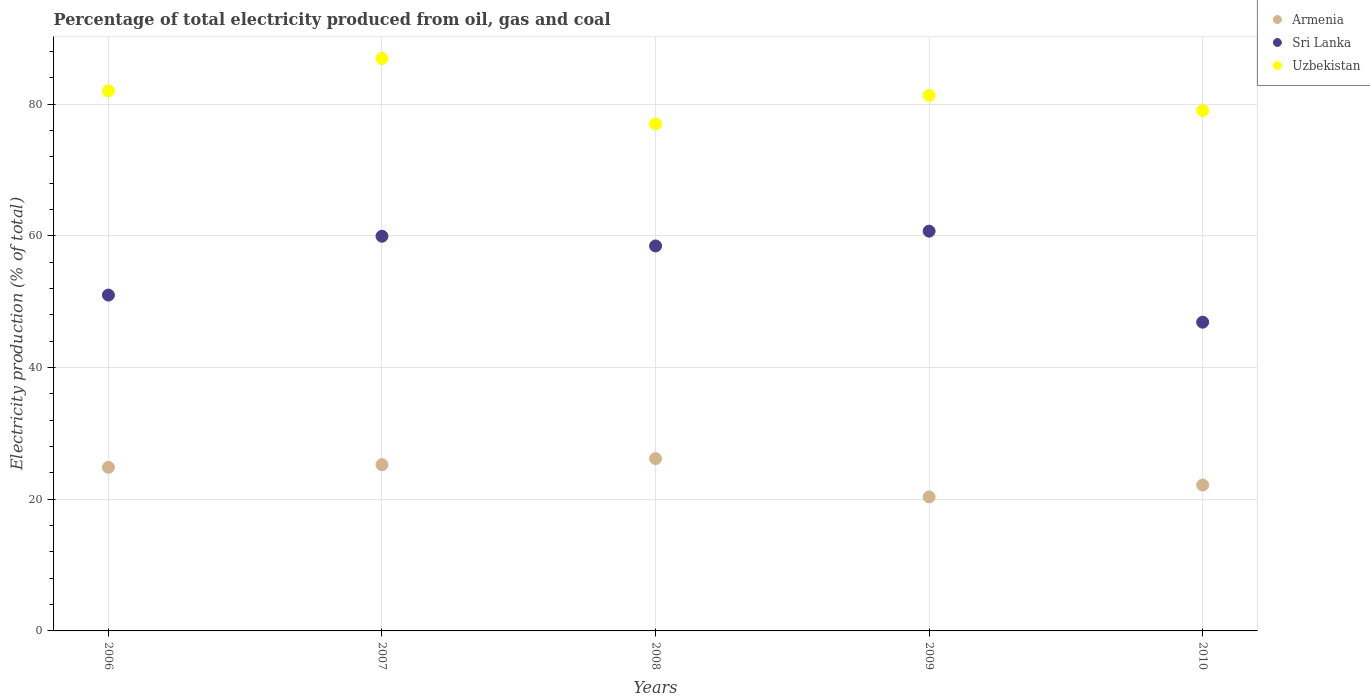How many different coloured dotlines are there?
Give a very brief answer. 3. Is the number of dotlines equal to the number of legend labels?
Your answer should be compact. Yes. What is the electricity production in in Armenia in 2006?
Provide a succinct answer. 24.84. Across all years, what is the maximum electricity production in in Uzbekistan?
Provide a succinct answer. 86.93. Across all years, what is the minimum electricity production in in Armenia?
Give a very brief answer. 20.35. In which year was the electricity production in in Sri Lanka minimum?
Keep it short and to the point. 2010. What is the total electricity production in in Sri Lanka in the graph?
Offer a very short reply. 276.98. What is the difference between the electricity production in in Sri Lanka in 2008 and that in 2009?
Provide a succinct answer. -2.24. What is the difference between the electricity production in in Sri Lanka in 2007 and the electricity production in in Uzbekistan in 2008?
Your answer should be compact. -17.07. What is the average electricity production in in Uzbekistan per year?
Make the answer very short. 81.26. In the year 2007, what is the difference between the electricity production in in Uzbekistan and electricity production in in Sri Lanka?
Offer a very short reply. 26.99. In how many years, is the electricity production in in Armenia greater than 72 %?
Provide a succinct answer. 0. What is the ratio of the electricity production in in Armenia in 2009 to that in 2010?
Your answer should be compact. 0.92. Is the difference between the electricity production in in Uzbekistan in 2008 and 2010 greater than the difference between the electricity production in in Sri Lanka in 2008 and 2010?
Make the answer very short. No. What is the difference between the highest and the second highest electricity production in in Uzbekistan?
Ensure brevity in your answer.  4.91. What is the difference between the highest and the lowest electricity production in in Sri Lanka?
Your answer should be compact. 13.82. In how many years, is the electricity production in in Uzbekistan greater than the average electricity production in in Uzbekistan taken over all years?
Give a very brief answer. 3. Is the sum of the electricity production in in Uzbekistan in 2007 and 2009 greater than the maximum electricity production in in Armenia across all years?
Offer a very short reply. Yes. Does the electricity production in in Sri Lanka monotonically increase over the years?
Your answer should be compact. No. How many years are there in the graph?
Offer a terse response. 5. Where does the legend appear in the graph?
Provide a succinct answer. Top right. What is the title of the graph?
Your response must be concise. Percentage of total electricity produced from oil, gas and coal. Does "Guatemala" appear as one of the legend labels in the graph?
Keep it short and to the point. No. What is the label or title of the X-axis?
Give a very brief answer. Years. What is the label or title of the Y-axis?
Your answer should be very brief. Electricity production (% of total). What is the Electricity production (% of total) in Armenia in 2006?
Your answer should be compact. 24.84. What is the Electricity production (% of total) in Sri Lanka in 2006?
Provide a succinct answer. 51. What is the Electricity production (% of total) in Uzbekistan in 2006?
Provide a short and direct response. 82.01. What is the Electricity production (% of total) of Armenia in 2007?
Make the answer very short. 25.25. What is the Electricity production (% of total) of Sri Lanka in 2007?
Offer a very short reply. 59.93. What is the Electricity production (% of total) of Uzbekistan in 2007?
Offer a terse response. 86.93. What is the Electricity production (% of total) in Armenia in 2008?
Your answer should be compact. 26.17. What is the Electricity production (% of total) of Sri Lanka in 2008?
Give a very brief answer. 58.46. What is the Electricity production (% of total) in Uzbekistan in 2008?
Offer a very short reply. 77. What is the Electricity production (% of total) of Armenia in 2009?
Provide a succinct answer. 20.35. What is the Electricity production (% of total) in Sri Lanka in 2009?
Provide a short and direct response. 60.7. What is the Electricity production (% of total) in Uzbekistan in 2009?
Ensure brevity in your answer.  81.32. What is the Electricity production (% of total) of Armenia in 2010?
Your response must be concise. 22.15. What is the Electricity production (% of total) of Sri Lanka in 2010?
Your answer should be very brief. 46.88. What is the Electricity production (% of total) of Uzbekistan in 2010?
Your answer should be very brief. 79.02. Across all years, what is the maximum Electricity production (% of total) in Armenia?
Provide a succinct answer. 26.17. Across all years, what is the maximum Electricity production (% of total) of Sri Lanka?
Make the answer very short. 60.7. Across all years, what is the maximum Electricity production (% of total) in Uzbekistan?
Your answer should be very brief. 86.93. Across all years, what is the minimum Electricity production (% of total) in Armenia?
Make the answer very short. 20.35. Across all years, what is the minimum Electricity production (% of total) in Sri Lanka?
Your response must be concise. 46.88. Across all years, what is the minimum Electricity production (% of total) in Uzbekistan?
Keep it short and to the point. 77. What is the total Electricity production (% of total) in Armenia in the graph?
Your answer should be very brief. 118.76. What is the total Electricity production (% of total) of Sri Lanka in the graph?
Provide a short and direct response. 276.98. What is the total Electricity production (% of total) in Uzbekistan in the graph?
Provide a succinct answer. 406.28. What is the difference between the Electricity production (% of total) of Armenia in 2006 and that in 2007?
Your answer should be very brief. -0.4. What is the difference between the Electricity production (% of total) of Sri Lanka in 2006 and that in 2007?
Provide a succinct answer. -8.93. What is the difference between the Electricity production (% of total) in Uzbekistan in 2006 and that in 2007?
Provide a short and direct response. -4.91. What is the difference between the Electricity production (% of total) in Armenia in 2006 and that in 2008?
Offer a terse response. -1.33. What is the difference between the Electricity production (% of total) in Sri Lanka in 2006 and that in 2008?
Provide a short and direct response. -7.46. What is the difference between the Electricity production (% of total) in Uzbekistan in 2006 and that in 2008?
Make the answer very short. 5.01. What is the difference between the Electricity production (% of total) in Armenia in 2006 and that in 2009?
Your answer should be compact. 4.5. What is the difference between the Electricity production (% of total) of Sri Lanka in 2006 and that in 2009?
Provide a succinct answer. -9.71. What is the difference between the Electricity production (% of total) in Uzbekistan in 2006 and that in 2009?
Give a very brief answer. 0.69. What is the difference between the Electricity production (% of total) in Armenia in 2006 and that in 2010?
Your response must be concise. 2.69. What is the difference between the Electricity production (% of total) in Sri Lanka in 2006 and that in 2010?
Keep it short and to the point. 4.12. What is the difference between the Electricity production (% of total) of Uzbekistan in 2006 and that in 2010?
Your answer should be very brief. 2.99. What is the difference between the Electricity production (% of total) of Armenia in 2007 and that in 2008?
Keep it short and to the point. -0.92. What is the difference between the Electricity production (% of total) of Sri Lanka in 2007 and that in 2008?
Provide a succinct answer. 1.47. What is the difference between the Electricity production (% of total) of Uzbekistan in 2007 and that in 2008?
Your answer should be very brief. 9.92. What is the difference between the Electricity production (% of total) in Armenia in 2007 and that in 2009?
Offer a terse response. 4.9. What is the difference between the Electricity production (% of total) in Sri Lanka in 2007 and that in 2009?
Give a very brief answer. -0.77. What is the difference between the Electricity production (% of total) in Uzbekistan in 2007 and that in 2009?
Your answer should be very brief. 5.6. What is the difference between the Electricity production (% of total) in Armenia in 2007 and that in 2010?
Offer a terse response. 3.09. What is the difference between the Electricity production (% of total) of Sri Lanka in 2007 and that in 2010?
Provide a short and direct response. 13.05. What is the difference between the Electricity production (% of total) in Uzbekistan in 2007 and that in 2010?
Offer a terse response. 7.9. What is the difference between the Electricity production (% of total) in Armenia in 2008 and that in 2009?
Ensure brevity in your answer.  5.82. What is the difference between the Electricity production (% of total) of Sri Lanka in 2008 and that in 2009?
Make the answer very short. -2.24. What is the difference between the Electricity production (% of total) of Uzbekistan in 2008 and that in 2009?
Keep it short and to the point. -4.32. What is the difference between the Electricity production (% of total) of Armenia in 2008 and that in 2010?
Provide a short and direct response. 4.02. What is the difference between the Electricity production (% of total) in Sri Lanka in 2008 and that in 2010?
Your answer should be compact. 11.58. What is the difference between the Electricity production (% of total) of Uzbekistan in 2008 and that in 2010?
Offer a very short reply. -2.02. What is the difference between the Electricity production (% of total) in Armenia in 2009 and that in 2010?
Your answer should be very brief. -1.8. What is the difference between the Electricity production (% of total) in Sri Lanka in 2009 and that in 2010?
Ensure brevity in your answer.  13.82. What is the difference between the Electricity production (% of total) of Uzbekistan in 2009 and that in 2010?
Make the answer very short. 2.3. What is the difference between the Electricity production (% of total) in Armenia in 2006 and the Electricity production (% of total) in Sri Lanka in 2007?
Your answer should be very brief. -35.09. What is the difference between the Electricity production (% of total) of Armenia in 2006 and the Electricity production (% of total) of Uzbekistan in 2007?
Make the answer very short. -62.08. What is the difference between the Electricity production (% of total) of Sri Lanka in 2006 and the Electricity production (% of total) of Uzbekistan in 2007?
Make the answer very short. -35.93. What is the difference between the Electricity production (% of total) of Armenia in 2006 and the Electricity production (% of total) of Sri Lanka in 2008?
Provide a short and direct response. -33.62. What is the difference between the Electricity production (% of total) in Armenia in 2006 and the Electricity production (% of total) in Uzbekistan in 2008?
Your response must be concise. -52.16. What is the difference between the Electricity production (% of total) of Sri Lanka in 2006 and the Electricity production (% of total) of Uzbekistan in 2008?
Provide a succinct answer. -26. What is the difference between the Electricity production (% of total) in Armenia in 2006 and the Electricity production (% of total) in Sri Lanka in 2009?
Keep it short and to the point. -35.86. What is the difference between the Electricity production (% of total) in Armenia in 2006 and the Electricity production (% of total) in Uzbekistan in 2009?
Your answer should be compact. -56.48. What is the difference between the Electricity production (% of total) in Sri Lanka in 2006 and the Electricity production (% of total) in Uzbekistan in 2009?
Make the answer very short. -30.32. What is the difference between the Electricity production (% of total) in Armenia in 2006 and the Electricity production (% of total) in Sri Lanka in 2010?
Your answer should be compact. -22.04. What is the difference between the Electricity production (% of total) of Armenia in 2006 and the Electricity production (% of total) of Uzbekistan in 2010?
Your response must be concise. -54.18. What is the difference between the Electricity production (% of total) in Sri Lanka in 2006 and the Electricity production (% of total) in Uzbekistan in 2010?
Your answer should be very brief. -28.02. What is the difference between the Electricity production (% of total) in Armenia in 2007 and the Electricity production (% of total) in Sri Lanka in 2008?
Provide a short and direct response. -33.21. What is the difference between the Electricity production (% of total) in Armenia in 2007 and the Electricity production (% of total) in Uzbekistan in 2008?
Offer a terse response. -51.76. What is the difference between the Electricity production (% of total) in Sri Lanka in 2007 and the Electricity production (% of total) in Uzbekistan in 2008?
Offer a terse response. -17.07. What is the difference between the Electricity production (% of total) of Armenia in 2007 and the Electricity production (% of total) of Sri Lanka in 2009?
Provide a short and direct response. -35.46. What is the difference between the Electricity production (% of total) in Armenia in 2007 and the Electricity production (% of total) in Uzbekistan in 2009?
Give a very brief answer. -56.08. What is the difference between the Electricity production (% of total) in Sri Lanka in 2007 and the Electricity production (% of total) in Uzbekistan in 2009?
Your answer should be very brief. -21.39. What is the difference between the Electricity production (% of total) in Armenia in 2007 and the Electricity production (% of total) in Sri Lanka in 2010?
Your answer should be compact. -21.64. What is the difference between the Electricity production (% of total) of Armenia in 2007 and the Electricity production (% of total) of Uzbekistan in 2010?
Ensure brevity in your answer.  -53.78. What is the difference between the Electricity production (% of total) in Sri Lanka in 2007 and the Electricity production (% of total) in Uzbekistan in 2010?
Ensure brevity in your answer.  -19.09. What is the difference between the Electricity production (% of total) of Armenia in 2008 and the Electricity production (% of total) of Sri Lanka in 2009?
Your answer should be compact. -34.54. What is the difference between the Electricity production (% of total) of Armenia in 2008 and the Electricity production (% of total) of Uzbekistan in 2009?
Make the answer very short. -55.15. What is the difference between the Electricity production (% of total) in Sri Lanka in 2008 and the Electricity production (% of total) in Uzbekistan in 2009?
Offer a terse response. -22.86. What is the difference between the Electricity production (% of total) of Armenia in 2008 and the Electricity production (% of total) of Sri Lanka in 2010?
Provide a short and direct response. -20.71. What is the difference between the Electricity production (% of total) in Armenia in 2008 and the Electricity production (% of total) in Uzbekistan in 2010?
Offer a terse response. -52.85. What is the difference between the Electricity production (% of total) in Sri Lanka in 2008 and the Electricity production (% of total) in Uzbekistan in 2010?
Provide a succinct answer. -20.56. What is the difference between the Electricity production (% of total) of Armenia in 2009 and the Electricity production (% of total) of Sri Lanka in 2010?
Give a very brief answer. -26.54. What is the difference between the Electricity production (% of total) of Armenia in 2009 and the Electricity production (% of total) of Uzbekistan in 2010?
Ensure brevity in your answer.  -58.67. What is the difference between the Electricity production (% of total) of Sri Lanka in 2009 and the Electricity production (% of total) of Uzbekistan in 2010?
Your answer should be compact. -18.32. What is the average Electricity production (% of total) of Armenia per year?
Your answer should be compact. 23.75. What is the average Electricity production (% of total) in Sri Lanka per year?
Your answer should be very brief. 55.4. What is the average Electricity production (% of total) in Uzbekistan per year?
Keep it short and to the point. 81.26. In the year 2006, what is the difference between the Electricity production (% of total) of Armenia and Electricity production (% of total) of Sri Lanka?
Your answer should be very brief. -26.16. In the year 2006, what is the difference between the Electricity production (% of total) of Armenia and Electricity production (% of total) of Uzbekistan?
Provide a succinct answer. -57.17. In the year 2006, what is the difference between the Electricity production (% of total) of Sri Lanka and Electricity production (% of total) of Uzbekistan?
Your answer should be very brief. -31.01. In the year 2007, what is the difference between the Electricity production (% of total) of Armenia and Electricity production (% of total) of Sri Lanka?
Your response must be concise. -34.69. In the year 2007, what is the difference between the Electricity production (% of total) in Armenia and Electricity production (% of total) in Uzbekistan?
Your answer should be compact. -61.68. In the year 2007, what is the difference between the Electricity production (% of total) of Sri Lanka and Electricity production (% of total) of Uzbekistan?
Provide a succinct answer. -26.99. In the year 2008, what is the difference between the Electricity production (% of total) of Armenia and Electricity production (% of total) of Sri Lanka?
Your answer should be very brief. -32.29. In the year 2008, what is the difference between the Electricity production (% of total) in Armenia and Electricity production (% of total) in Uzbekistan?
Ensure brevity in your answer.  -50.83. In the year 2008, what is the difference between the Electricity production (% of total) of Sri Lanka and Electricity production (% of total) of Uzbekistan?
Your answer should be compact. -18.54. In the year 2009, what is the difference between the Electricity production (% of total) in Armenia and Electricity production (% of total) in Sri Lanka?
Provide a succinct answer. -40.36. In the year 2009, what is the difference between the Electricity production (% of total) of Armenia and Electricity production (% of total) of Uzbekistan?
Provide a succinct answer. -60.97. In the year 2009, what is the difference between the Electricity production (% of total) of Sri Lanka and Electricity production (% of total) of Uzbekistan?
Offer a very short reply. -20.62. In the year 2010, what is the difference between the Electricity production (% of total) of Armenia and Electricity production (% of total) of Sri Lanka?
Provide a short and direct response. -24.73. In the year 2010, what is the difference between the Electricity production (% of total) of Armenia and Electricity production (% of total) of Uzbekistan?
Your answer should be compact. -56.87. In the year 2010, what is the difference between the Electricity production (% of total) in Sri Lanka and Electricity production (% of total) in Uzbekistan?
Ensure brevity in your answer.  -32.14. What is the ratio of the Electricity production (% of total) in Armenia in 2006 to that in 2007?
Ensure brevity in your answer.  0.98. What is the ratio of the Electricity production (% of total) in Sri Lanka in 2006 to that in 2007?
Provide a short and direct response. 0.85. What is the ratio of the Electricity production (% of total) of Uzbekistan in 2006 to that in 2007?
Your answer should be very brief. 0.94. What is the ratio of the Electricity production (% of total) in Armenia in 2006 to that in 2008?
Offer a very short reply. 0.95. What is the ratio of the Electricity production (% of total) in Sri Lanka in 2006 to that in 2008?
Keep it short and to the point. 0.87. What is the ratio of the Electricity production (% of total) in Uzbekistan in 2006 to that in 2008?
Your answer should be very brief. 1.06. What is the ratio of the Electricity production (% of total) of Armenia in 2006 to that in 2009?
Ensure brevity in your answer.  1.22. What is the ratio of the Electricity production (% of total) in Sri Lanka in 2006 to that in 2009?
Make the answer very short. 0.84. What is the ratio of the Electricity production (% of total) of Uzbekistan in 2006 to that in 2009?
Your answer should be very brief. 1.01. What is the ratio of the Electricity production (% of total) in Armenia in 2006 to that in 2010?
Provide a succinct answer. 1.12. What is the ratio of the Electricity production (% of total) in Sri Lanka in 2006 to that in 2010?
Your answer should be very brief. 1.09. What is the ratio of the Electricity production (% of total) in Uzbekistan in 2006 to that in 2010?
Provide a short and direct response. 1.04. What is the ratio of the Electricity production (% of total) in Armenia in 2007 to that in 2008?
Give a very brief answer. 0.96. What is the ratio of the Electricity production (% of total) of Sri Lanka in 2007 to that in 2008?
Make the answer very short. 1.03. What is the ratio of the Electricity production (% of total) in Uzbekistan in 2007 to that in 2008?
Offer a very short reply. 1.13. What is the ratio of the Electricity production (% of total) of Armenia in 2007 to that in 2009?
Provide a succinct answer. 1.24. What is the ratio of the Electricity production (% of total) in Sri Lanka in 2007 to that in 2009?
Provide a short and direct response. 0.99. What is the ratio of the Electricity production (% of total) in Uzbekistan in 2007 to that in 2009?
Provide a succinct answer. 1.07. What is the ratio of the Electricity production (% of total) in Armenia in 2007 to that in 2010?
Offer a terse response. 1.14. What is the ratio of the Electricity production (% of total) of Sri Lanka in 2007 to that in 2010?
Provide a succinct answer. 1.28. What is the ratio of the Electricity production (% of total) of Uzbekistan in 2007 to that in 2010?
Ensure brevity in your answer.  1.1. What is the ratio of the Electricity production (% of total) of Armenia in 2008 to that in 2009?
Provide a succinct answer. 1.29. What is the ratio of the Electricity production (% of total) of Uzbekistan in 2008 to that in 2009?
Keep it short and to the point. 0.95. What is the ratio of the Electricity production (% of total) of Armenia in 2008 to that in 2010?
Make the answer very short. 1.18. What is the ratio of the Electricity production (% of total) in Sri Lanka in 2008 to that in 2010?
Your answer should be compact. 1.25. What is the ratio of the Electricity production (% of total) in Uzbekistan in 2008 to that in 2010?
Keep it short and to the point. 0.97. What is the ratio of the Electricity production (% of total) of Armenia in 2009 to that in 2010?
Your answer should be very brief. 0.92. What is the ratio of the Electricity production (% of total) of Sri Lanka in 2009 to that in 2010?
Ensure brevity in your answer.  1.29. What is the ratio of the Electricity production (% of total) of Uzbekistan in 2009 to that in 2010?
Give a very brief answer. 1.03. What is the difference between the highest and the second highest Electricity production (% of total) in Armenia?
Your response must be concise. 0.92. What is the difference between the highest and the second highest Electricity production (% of total) in Sri Lanka?
Your answer should be compact. 0.77. What is the difference between the highest and the second highest Electricity production (% of total) in Uzbekistan?
Ensure brevity in your answer.  4.91. What is the difference between the highest and the lowest Electricity production (% of total) in Armenia?
Provide a succinct answer. 5.82. What is the difference between the highest and the lowest Electricity production (% of total) in Sri Lanka?
Provide a succinct answer. 13.82. What is the difference between the highest and the lowest Electricity production (% of total) of Uzbekistan?
Offer a terse response. 9.92. 